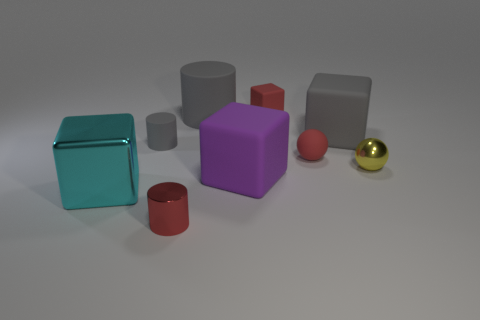The cyan metallic object that is the same shape as the purple thing is what size?
Offer a very short reply. Large. What is the size of the purple thing?
Your answer should be compact. Large. Do the red rubber thing behind the small red sphere and the cyan metallic thing have the same shape?
Ensure brevity in your answer.  Yes. There is a small matte thing behind the large rubber cylinder; is it the same color as the tiny thing that is in front of the large purple matte block?
Your answer should be very brief. Yes. What is the material of the small object that is both right of the red shiny cylinder and behind the tiny rubber sphere?
Your answer should be very brief. Rubber. The large cylinder is what color?
Give a very brief answer. Gray. How many other objects are there of the same shape as the cyan metal object?
Keep it short and to the point. 3. Are there the same number of purple objects that are to the left of the red cube and cylinders behind the purple rubber object?
Keep it short and to the point. No. What material is the purple thing?
Offer a very short reply. Rubber. What material is the red thing that is left of the purple matte object?
Your answer should be very brief. Metal. 